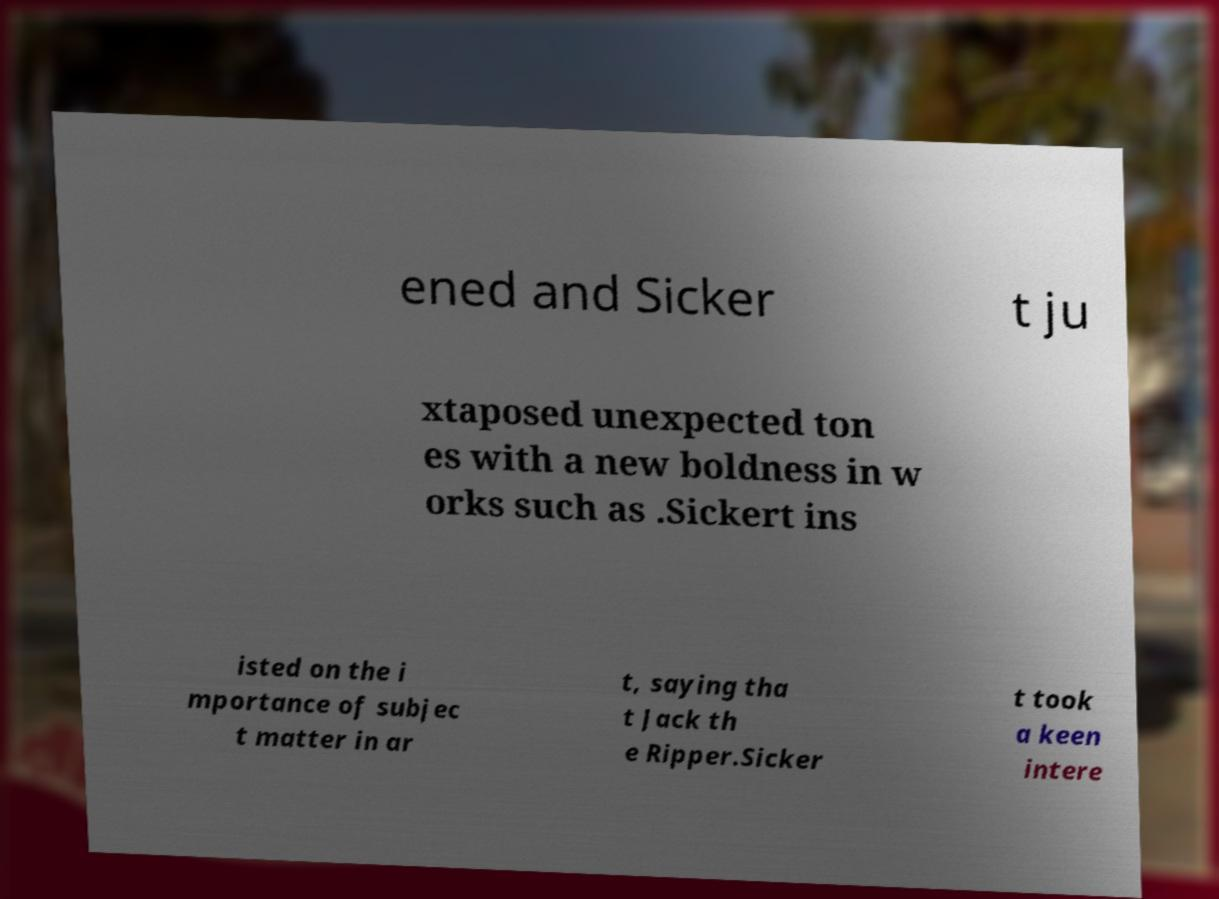Please identify and transcribe the text found in this image. ened and Sicker t ju xtaposed unexpected ton es with a new boldness in w orks such as .Sickert ins isted on the i mportance of subjec t matter in ar t, saying tha t Jack th e Ripper.Sicker t took a keen intere 